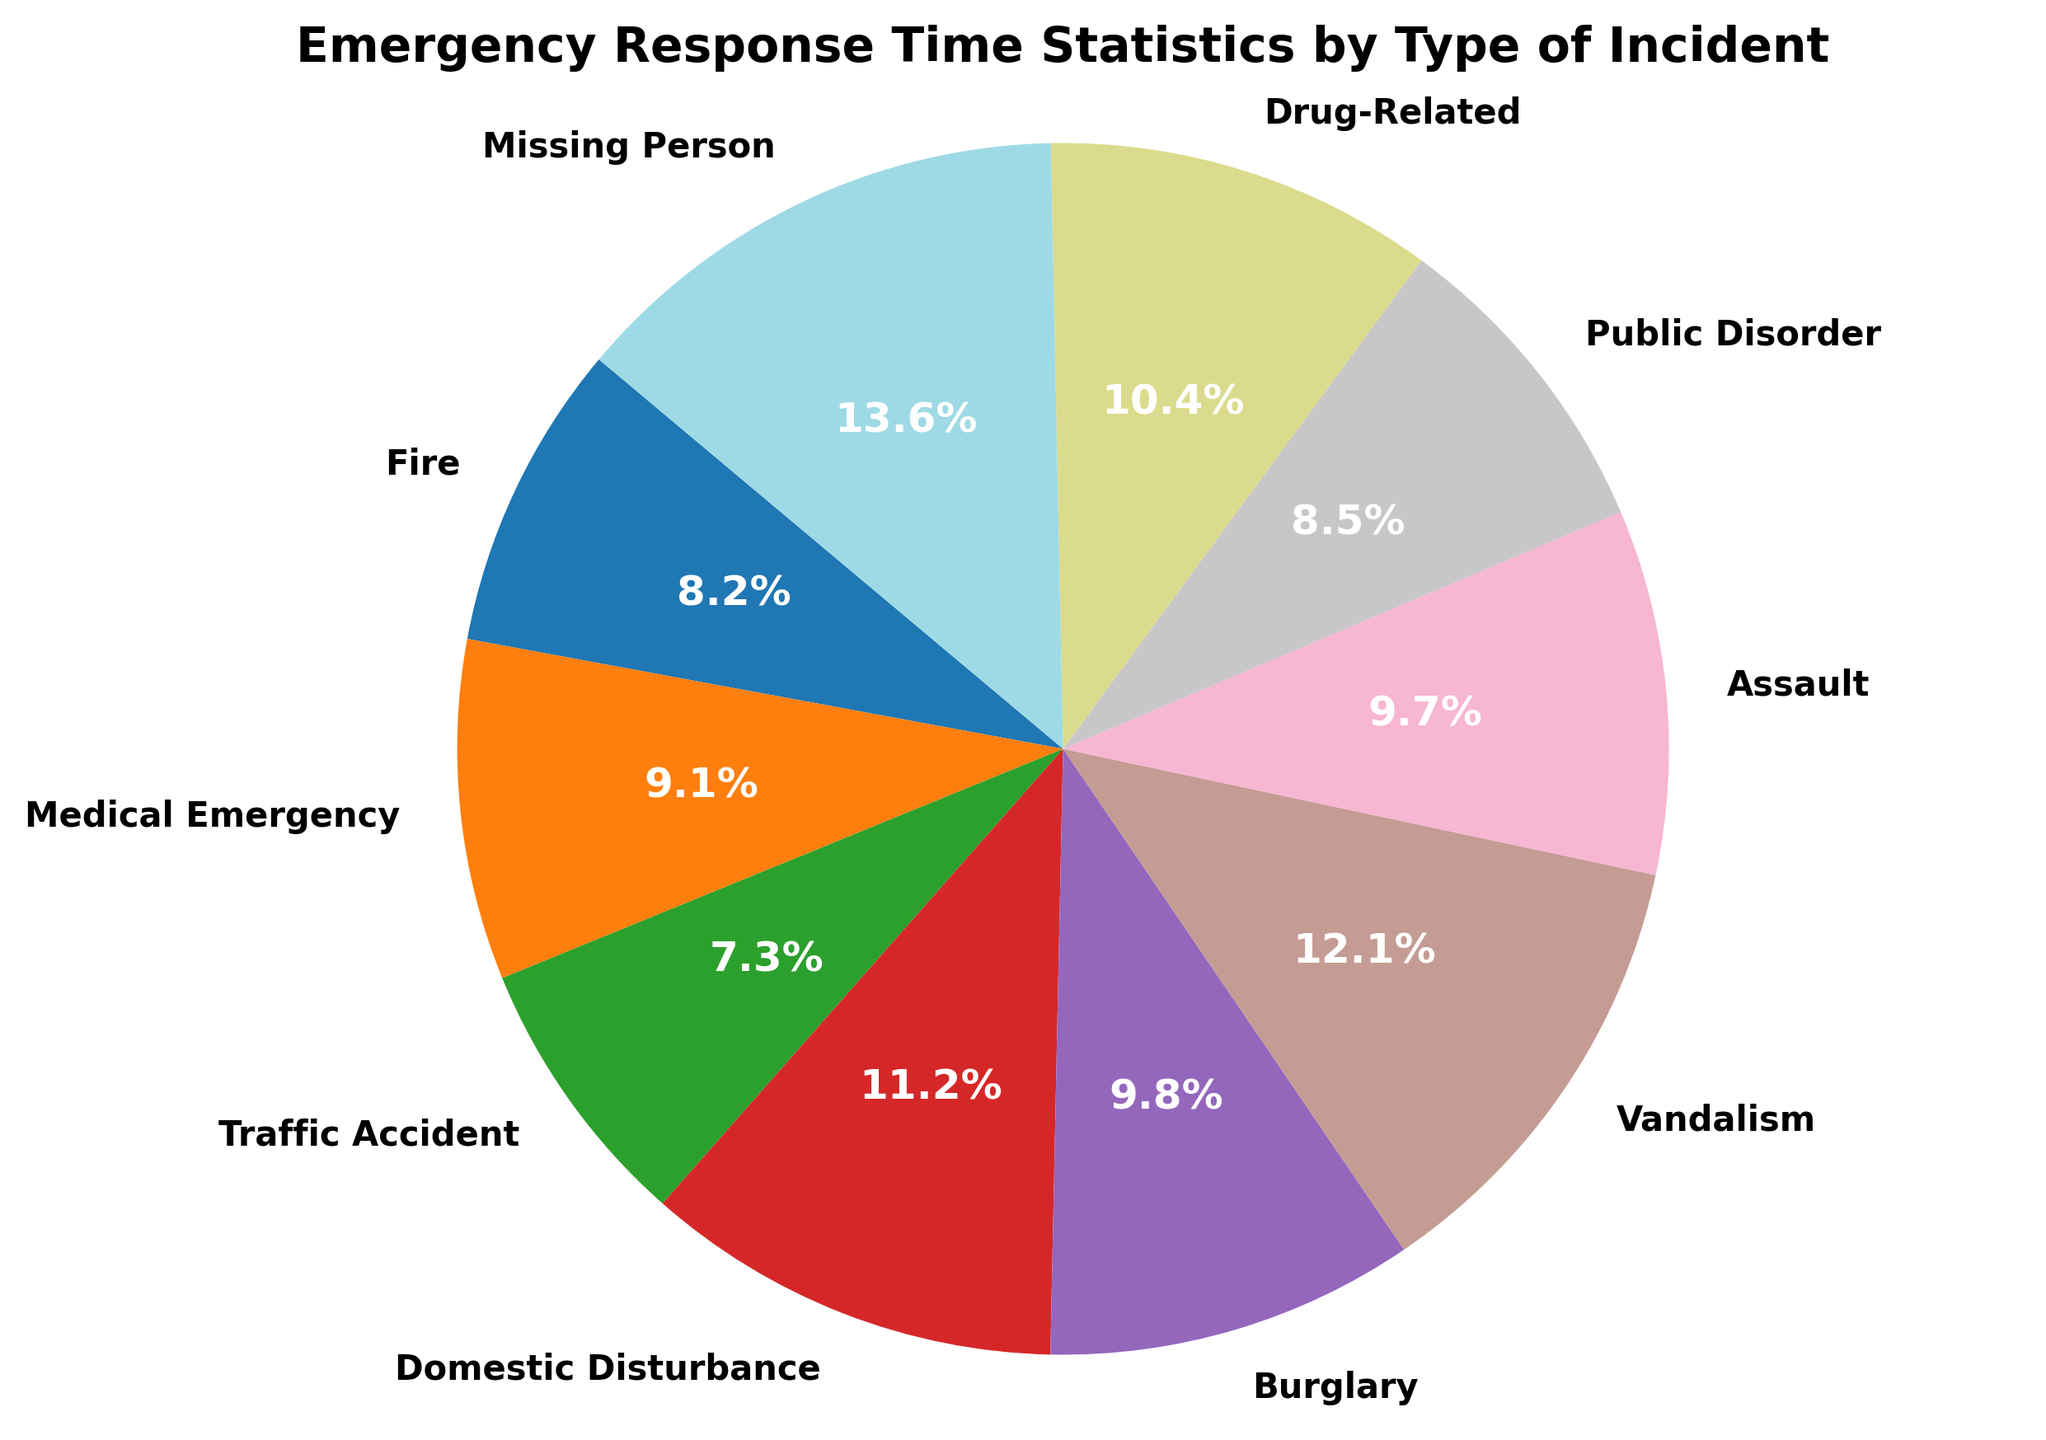What is the average response time for all incidents combined? To find the average response time, add all the response times and then divide by the number of incidents. The sum of response times is 7.5 + 8.3 + 6.7 + 10.2 + 9.0 + 11.1 + 8.9 + 7.8 + 9.5 + 12.4 = 91.4 minutes. There are 10 incidents, so the average is 91.4 / 10 = 9.14 minutes
Answer: 9.14 minutes Which incident type has the fastest response time? By comparing the response times of all the incidents, the incident type with the lowest value is identified. Out of all the response times listed, "Traffic Accident" has the fastest response time of 6.7 minutes
Answer: Traffic Accident Which incident type has the slowest response time? By comparing the response times of all the incidents, the incident type with the highest value is identified. "Missing Person" has the slowest response time of 12.4 minutes
Answer: Missing Person What is the response time difference between the fastest and slowest incident types? The fastest response time is for "Traffic Accident" at 6.7 minutes and the slowest response time is for "Missing Person" at 12.4 minutes. The difference is 12.4 - 6.7 = 5.7 minutes
Answer: 5.7 minutes How many incident types have a response time of more than 10 minutes? By visually inspecting the pie chart, you can identify the incidents with response times greater than 10 minutes. "Domestic Disturbance" (10.2 minutes), "Vandalism" (11.1 minutes), and "Missing Person" (12.4 minutes) have response times greater than 10 minutes. There are 3 such incidents
Answer: 3 Compare the response times for "Fire" and "Public Disorder". Which one is faster? By comparing the response times for "Fire" and "Public Disorder," you see that "Fire" has a response time of 7.5 minutes and "Public Disorder" has 7.8 minutes. So "Fire" is faster
Answer: Fire What is the sum of response times for "Burglary" and "Assault"? To find the sum of response times for "Burglary" and "Assault," add their response times. Burglary has a response time of 9.0 minutes and Assault has 8.9 minutes. The sum is 9.0 + 8.9 = 17.9 minutes
Answer: 17.9 minutes Which incident type has a response time closest to 10 minutes? By locating the incidents with response times around 10 minutes, you can see that "Domestic Disturbance" has a response time very close to 10 minutes, it is 10.2 minutes
Answer: Domestic Disturbance What percentage of total response time does "Medical Emergency" occupy? First, calculate the total response time, which is 91.4 minutes. Then, find the percentage of the total response time that "Medical Emergency" occupies. (8.3 / 91.4) * 100 ≈ 9.1%
Answer: 9.1% 